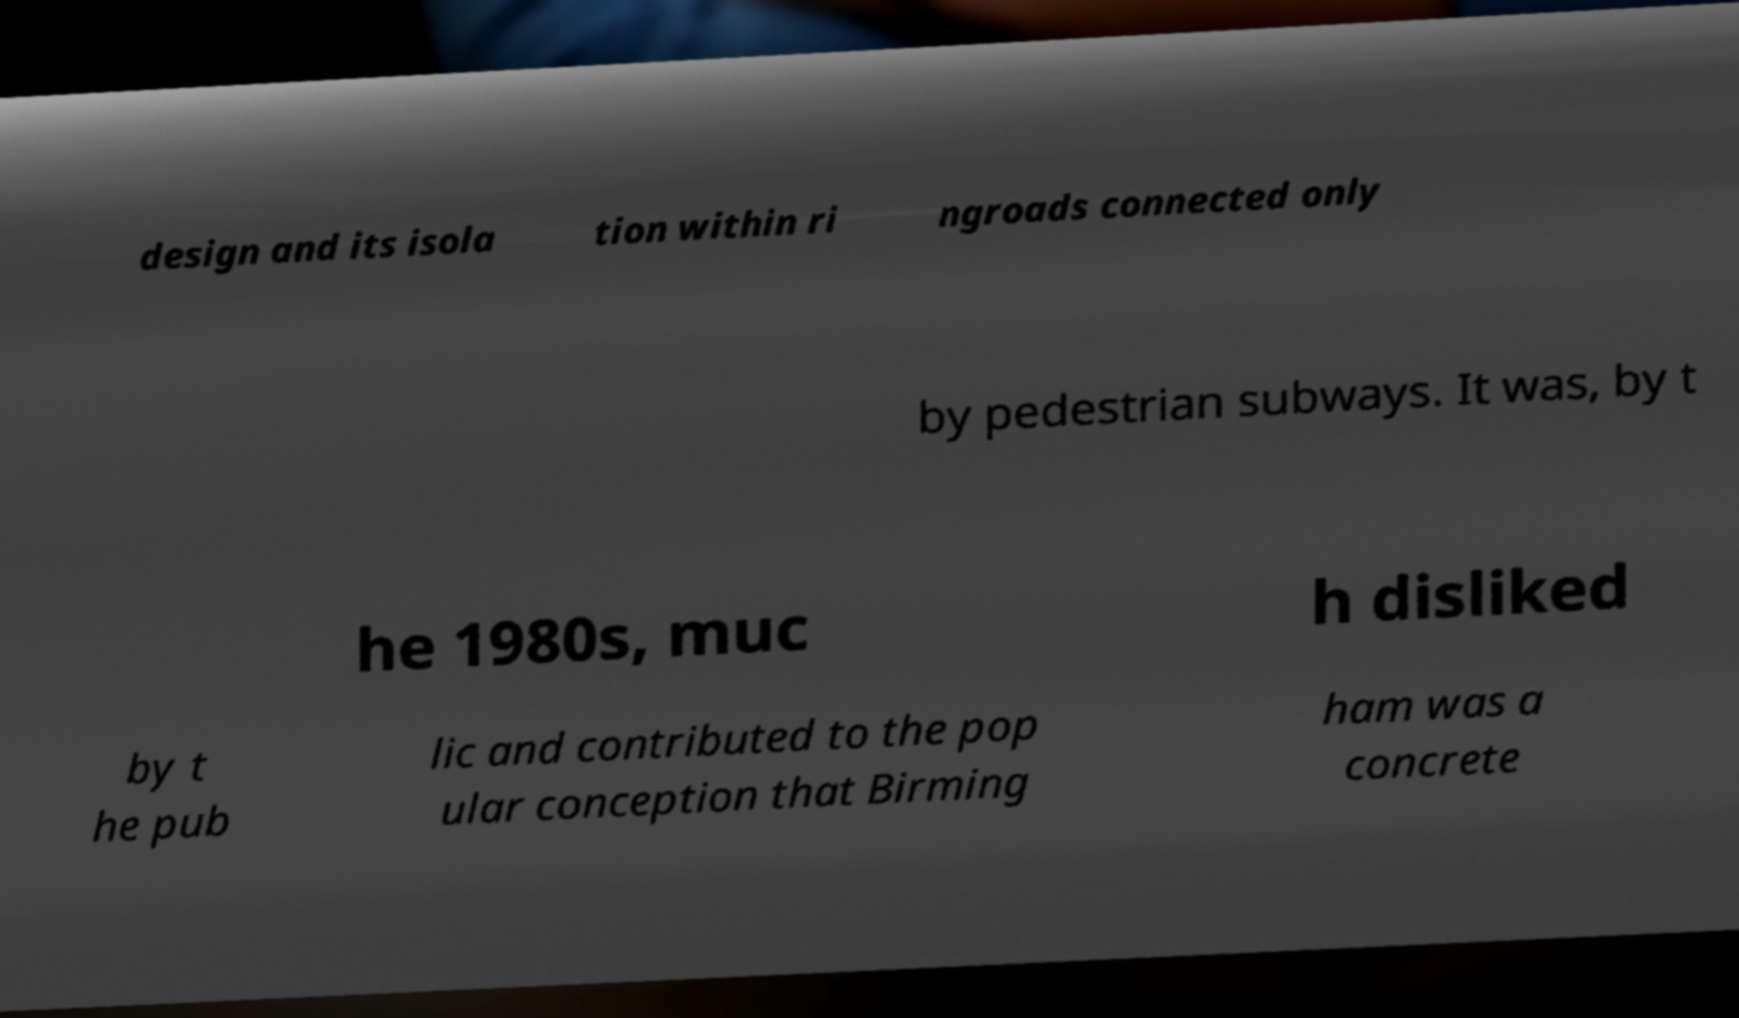Can you read and provide the text displayed in the image?This photo seems to have some interesting text. Can you extract and type it out for me? design and its isola tion within ri ngroads connected only by pedestrian subways. It was, by t he 1980s, muc h disliked by t he pub lic and contributed to the pop ular conception that Birming ham was a concrete 